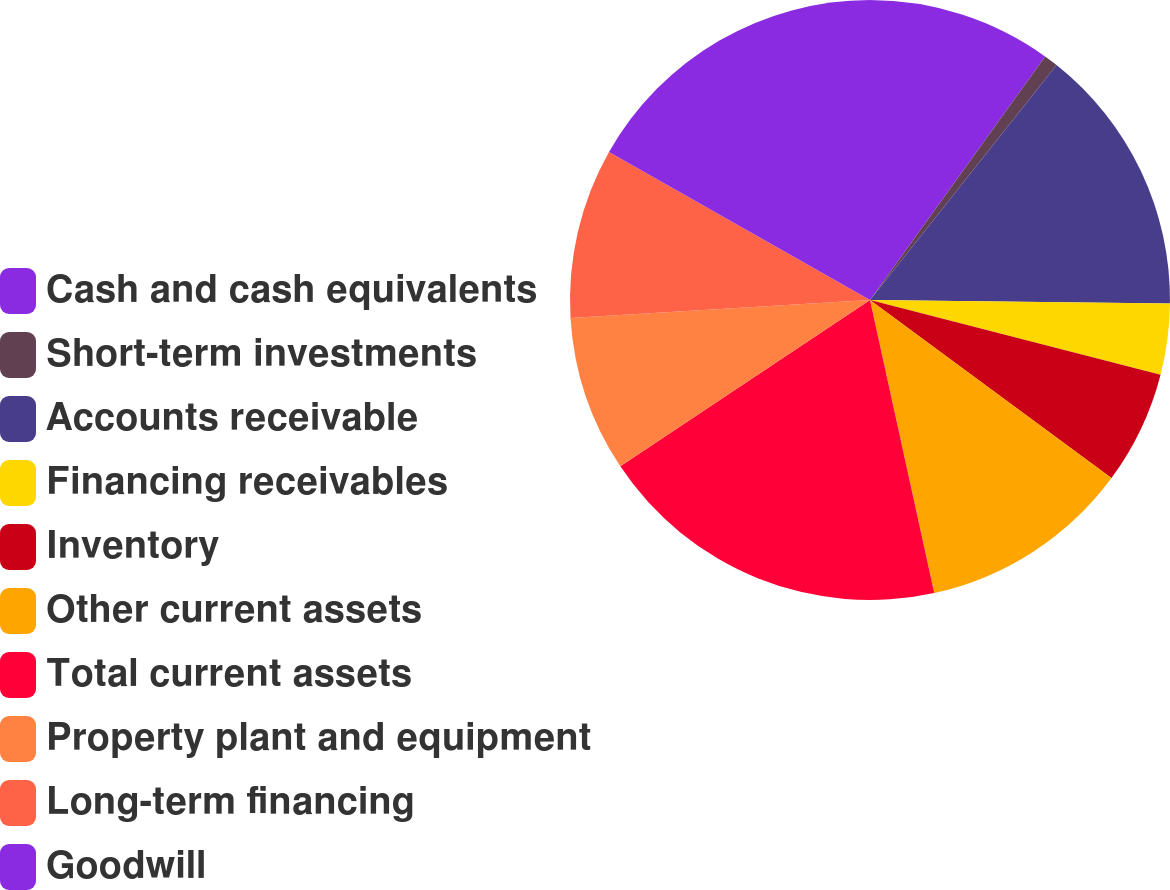Convert chart to OTSL. <chart><loc_0><loc_0><loc_500><loc_500><pie_chart><fcel>Cash and cash equivalents<fcel>Short-term investments<fcel>Accounts receivable<fcel>Financing receivables<fcel>Inventory<fcel>Other current assets<fcel>Total current assets<fcel>Property plant and equipment<fcel>Long-term financing<fcel>Goodwill<nl><fcel>9.92%<fcel>0.76%<fcel>14.5%<fcel>3.82%<fcel>6.11%<fcel>11.45%<fcel>19.08%<fcel>8.4%<fcel>9.16%<fcel>16.79%<nl></chart> 